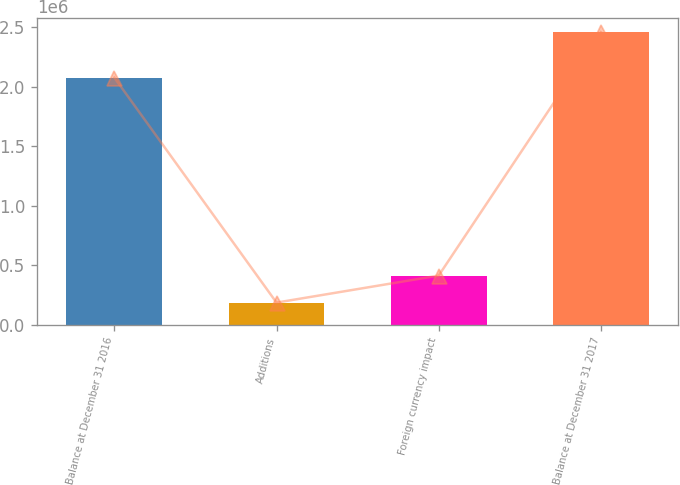<chart> <loc_0><loc_0><loc_500><loc_500><bar_chart><fcel>Balance at December 31 2016<fcel>Additions<fcel>Foreign currency impact<fcel>Balance at December 31 2017<nl><fcel>2.07876e+06<fcel>186487<fcel>413849<fcel>2.4601e+06<nl></chart> 